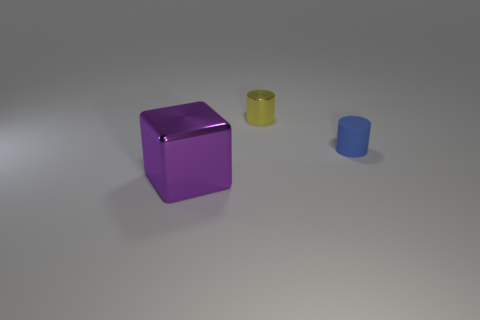Is the material of the tiny blue object that is in front of the small metallic cylinder the same as the object that is left of the metal cylinder?
Ensure brevity in your answer.  No. Are there fewer purple metallic objects in front of the big cube than tiny yellow shiny things?
Provide a short and direct response. Yes. How many blue cylinders are behind the shiny thing on the right side of the large purple metallic object?
Keep it short and to the point. 0. There is a object that is in front of the yellow thing and on the left side of the tiny rubber object; what is its size?
Your answer should be compact. Large. Is there any other thing that has the same material as the blue object?
Your response must be concise. No. Is the cube made of the same material as the small cylinder that is in front of the tiny shiny cylinder?
Your answer should be very brief. No. Is the number of blue objects that are in front of the shiny block less than the number of blue cylinders that are right of the yellow metallic thing?
Keep it short and to the point. Yes. What is the material of the cylinder that is left of the blue object?
Your answer should be very brief. Metal. What is the color of the object that is right of the metal block and in front of the tiny yellow cylinder?
Offer a very short reply. Blue. What number of other objects are the same color as the small rubber cylinder?
Ensure brevity in your answer.  0. 